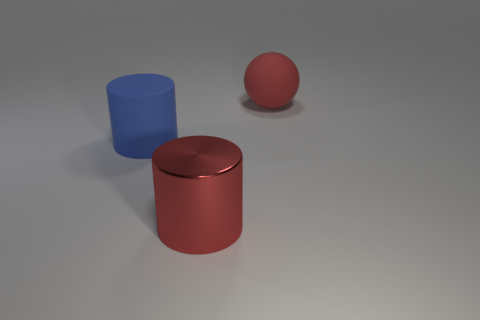The thing behind the rubber thing that is in front of the big red object right of the shiny object is made of what material?
Your answer should be very brief. Rubber. Is there a big brown ball that has the same material as the red sphere?
Your response must be concise. No. Are the red cylinder and the blue object made of the same material?
Ensure brevity in your answer.  No. How many blocks are either objects or rubber objects?
Your response must be concise. 0. What is the color of the ball that is the same material as the big blue thing?
Keep it short and to the point. Red. Is the number of red matte balls less than the number of tiny blue shiny cylinders?
Make the answer very short. No. There is a rubber thing to the left of the large metallic object; does it have the same shape as the red object that is in front of the big blue thing?
Offer a terse response. Yes. What number of objects are either big red metallic things or large blue matte cylinders?
Your response must be concise. 2. There is a rubber cylinder that is the same size as the red metallic object; what color is it?
Your answer should be very brief. Blue. There is a blue rubber thing that is left of the big metallic object; how many metal cylinders are on the left side of it?
Provide a short and direct response. 0. 